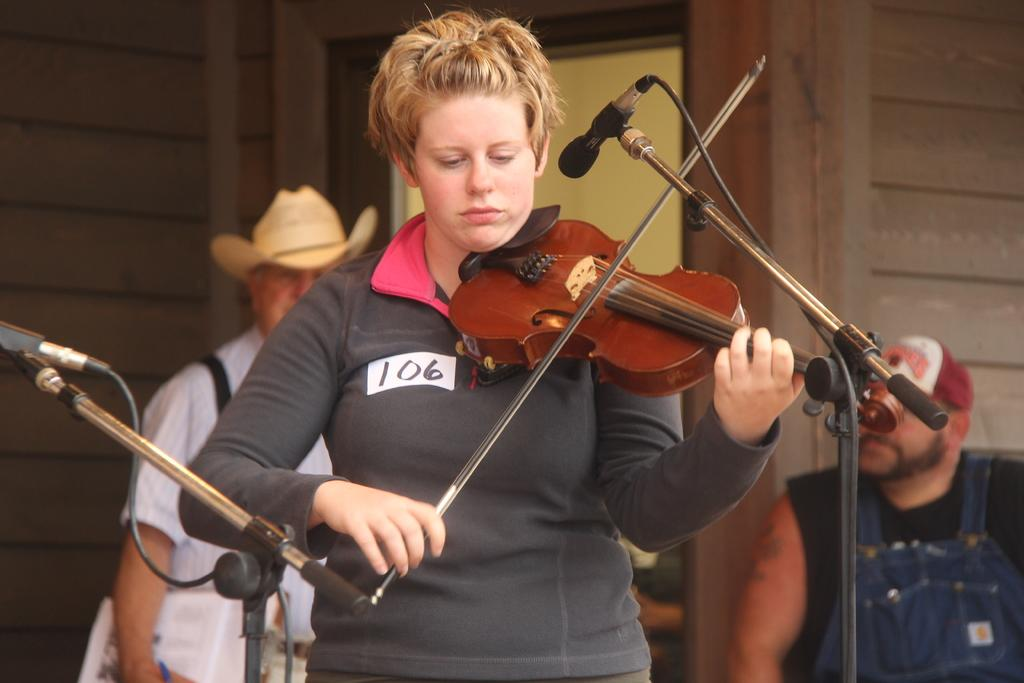What is the main activity being performed by the person in the image? There is a person playing a guitar in the image. What objects are present that might be related to the activity? There are mikes in the image. How many other people are in the image? There are two other persons in the image. What can be seen in the background of the image? There is a wall and an unspecified object in the background of the image. What time of day is it in the image, and what type of pan is being used by the person playing the guitar? The time of day is not specified in the image, and there is no pan present in the image. 